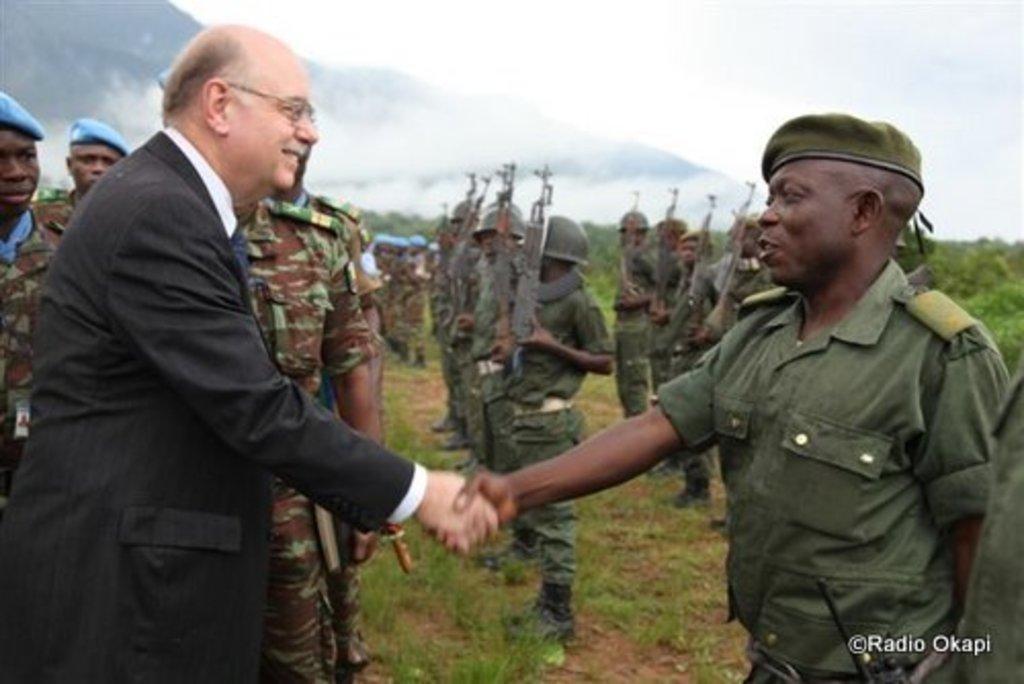In one or two sentences, can you explain what this image depicts? In this picture, we can see a few people and among them two are holding their hands, and we can see the ground, grass, plants, mountains, and we can see some text in the bottom right side of the picture. 